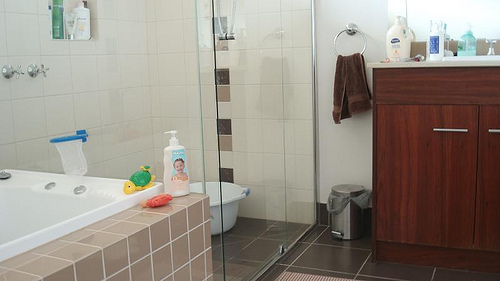Imagine yourself as an object in this bathroom, what would you be and why? If I were an object in this bathroom, I would be the cheerful yellow and green turtle toy, bringing a splash of fun and playfulness to the otherwise functional space. 